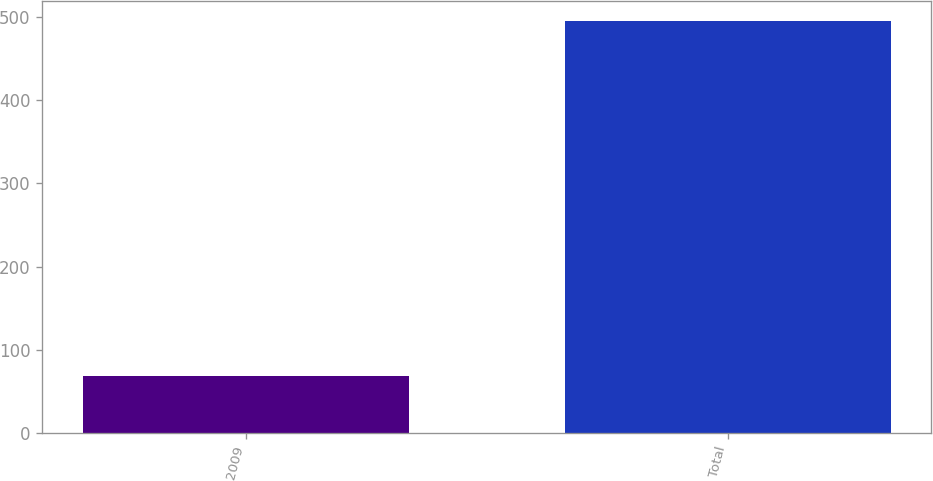<chart> <loc_0><loc_0><loc_500><loc_500><bar_chart><fcel>2009<fcel>Total<nl><fcel>68<fcel>495<nl></chart> 